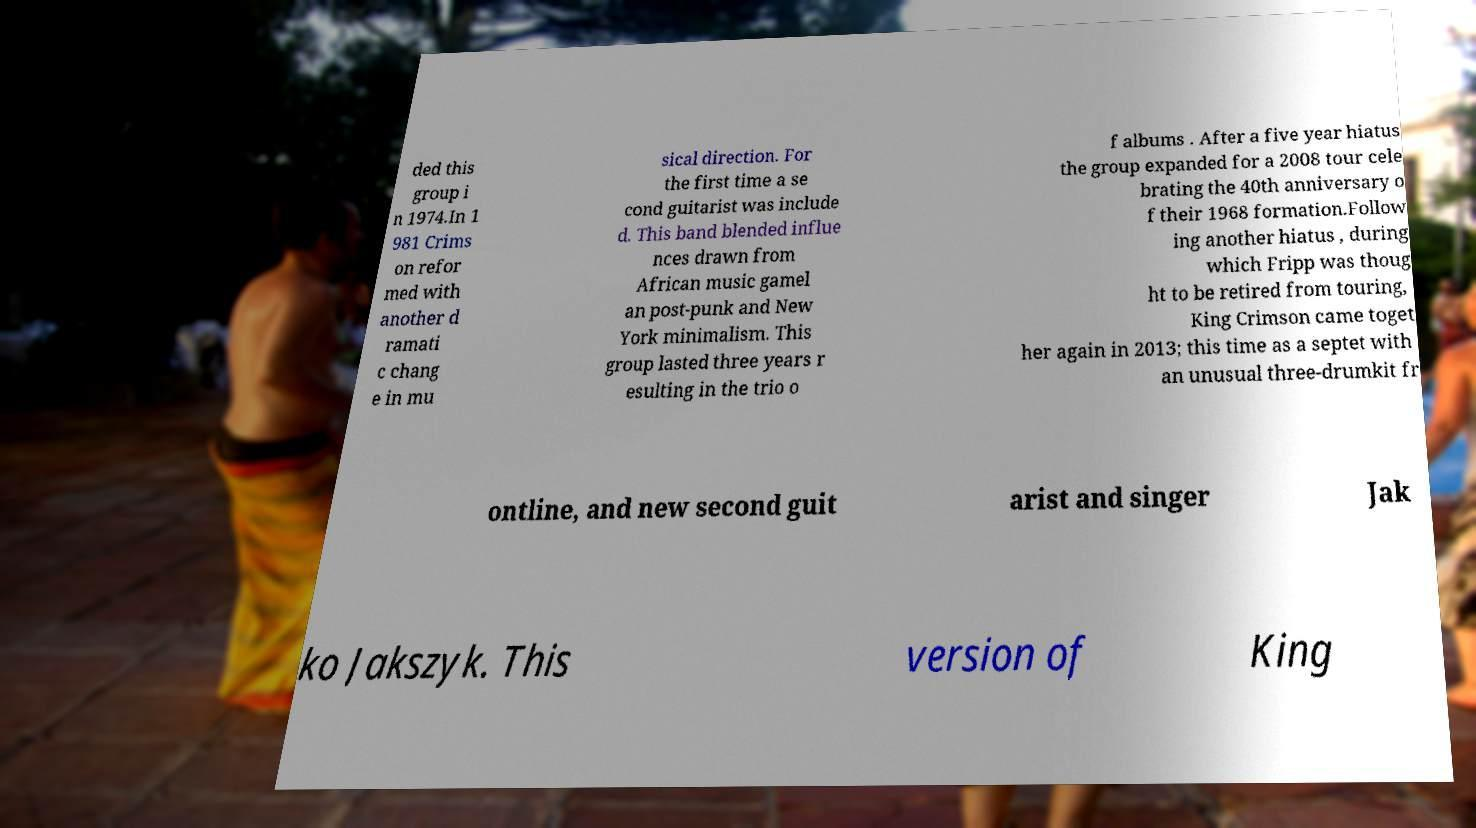Could you assist in decoding the text presented in this image and type it out clearly? ded this group i n 1974.In 1 981 Crims on refor med with another d ramati c chang e in mu sical direction. For the first time a se cond guitarist was include d. This band blended influe nces drawn from African music gamel an post-punk and New York minimalism. This group lasted three years r esulting in the trio o f albums . After a five year hiatus the group expanded for a 2008 tour cele brating the 40th anniversary o f their 1968 formation.Follow ing another hiatus , during which Fripp was thoug ht to be retired from touring, King Crimson came toget her again in 2013; this time as a septet with an unusual three-drumkit fr ontline, and new second guit arist and singer Jak ko Jakszyk. This version of King 